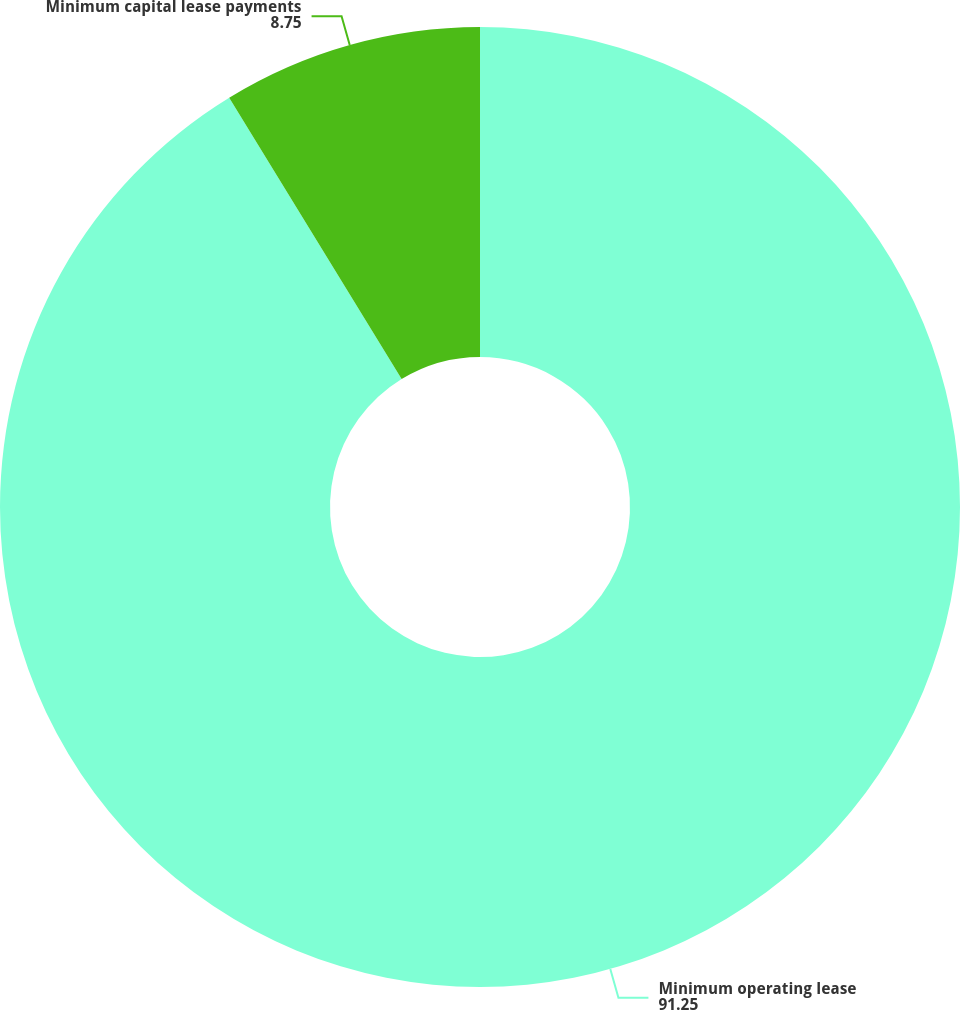Convert chart to OTSL. <chart><loc_0><loc_0><loc_500><loc_500><pie_chart><fcel>Minimum operating lease<fcel>Minimum capital lease payments<nl><fcel>91.25%<fcel>8.75%<nl></chart> 